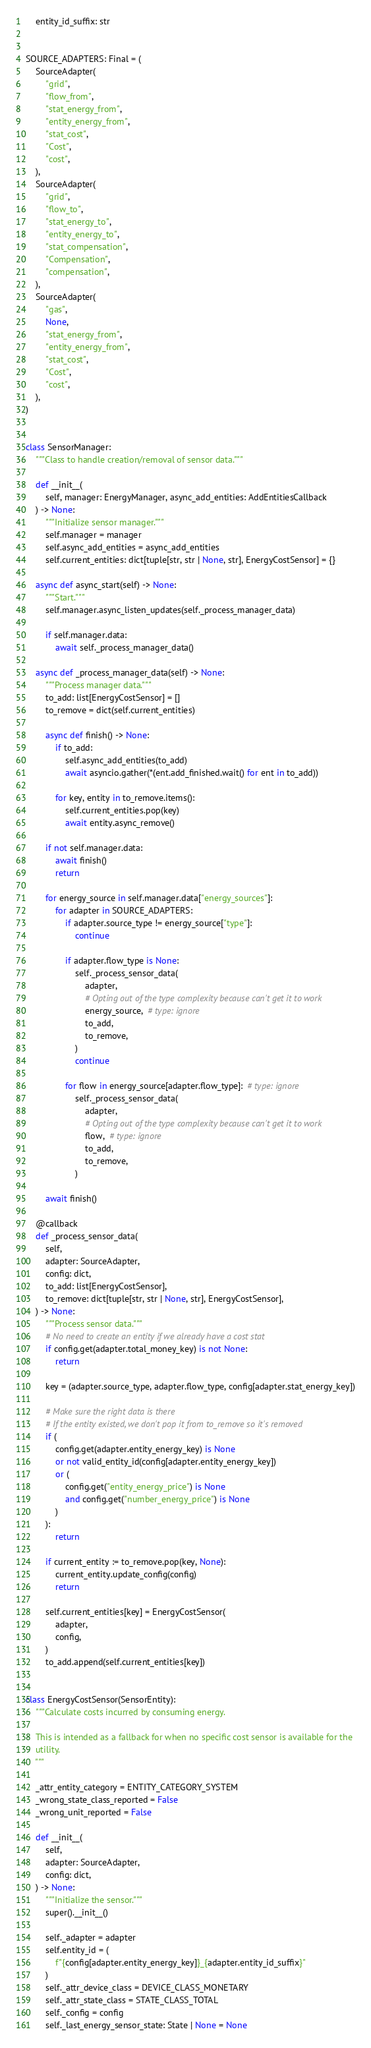<code> <loc_0><loc_0><loc_500><loc_500><_Python_>    entity_id_suffix: str


SOURCE_ADAPTERS: Final = (
    SourceAdapter(
        "grid",
        "flow_from",
        "stat_energy_from",
        "entity_energy_from",
        "stat_cost",
        "Cost",
        "cost",
    ),
    SourceAdapter(
        "grid",
        "flow_to",
        "stat_energy_to",
        "entity_energy_to",
        "stat_compensation",
        "Compensation",
        "compensation",
    ),
    SourceAdapter(
        "gas",
        None,
        "stat_energy_from",
        "entity_energy_from",
        "stat_cost",
        "Cost",
        "cost",
    ),
)


class SensorManager:
    """Class to handle creation/removal of sensor data."""

    def __init__(
        self, manager: EnergyManager, async_add_entities: AddEntitiesCallback
    ) -> None:
        """Initialize sensor manager."""
        self.manager = manager
        self.async_add_entities = async_add_entities
        self.current_entities: dict[tuple[str, str | None, str], EnergyCostSensor] = {}

    async def async_start(self) -> None:
        """Start."""
        self.manager.async_listen_updates(self._process_manager_data)

        if self.manager.data:
            await self._process_manager_data()

    async def _process_manager_data(self) -> None:
        """Process manager data."""
        to_add: list[EnergyCostSensor] = []
        to_remove = dict(self.current_entities)

        async def finish() -> None:
            if to_add:
                self.async_add_entities(to_add)
                await asyncio.gather(*(ent.add_finished.wait() for ent in to_add))

            for key, entity in to_remove.items():
                self.current_entities.pop(key)
                await entity.async_remove()

        if not self.manager.data:
            await finish()
            return

        for energy_source in self.manager.data["energy_sources"]:
            for adapter in SOURCE_ADAPTERS:
                if adapter.source_type != energy_source["type"]:
                    continue

                if adapter.flow_type is None:
                    self._process_sensor_data(
                        adapter,
                        # Opting out of the type complexity because can't get it to work
                        energy_source,  # type: ignore
                        to_add,
                        to_remove,
                    )
                    continue

                for flow in energy_source[adapter.flow_type]:  # type: ignore
                    self._process_sensor_data(
                        adapter,
                        # Opting out of the type complexity because can't get it to work
                        flow,  # type: ignore
                        to_add,
                        to_remove,
                    )

        await finish()

    @callback
    def _process_sensor_data(
        self,
        adapter: SourceAdapter,
        config: dict,
        to_add: list[EnergyCostSensor],
        to_remove: dict[tuple[str, str | None, str], EnergyCostSensor],
    ) -> None:
        """Process sensor data."""
        # No need to create an entity if we already have a cost stat
        if config.get(adapter.total_money_key) is not None:
            return

        key = (adapter.source_type, adapter.flow_type, config[adapter.stat_energy_key])

        # Make sure the right data is there
        # If the entity existed, we don't pop it from to_remove so it's removed
        if (
            config.get(adapter.entity_energy_key) is None
            or not valid_entity_id(config[adapter.entity_energy_key])
            or (
                config.get("entity_energy_price") is None
                and config.get("number_energy_price") is None
            )
        ):
            return

        if current_entity := to_remove.pop(key, None):
            current_entity.update_config(config)
            return

        self.current_entities[key] = EnergyCostSensor(
            adapter,
            config,
        )
        to_add.append(self.current_entities[key])


class EnergyCostSensor(SensorEntity):
    """Calculate costs incurred by consuming energy.

    This is intended as a fallback for when no specific cost sensor is available for the
    utility.
    """

    _attr_entity_category = ENTITY_CATEGORY_SYSTEM
    _wrong_state_class_reported = False
    _wrong_unit_reported = False

    def __init__(
        self,
        adapter: SourceAdapter,
        config: dict,
    ) -> None:
        """Initialize the sensor."""
        super().__init__()

        self._adapter = adapter
        self.entity_id = (
            f"{config[adapter.entity_energy_key]}_{adapter.entity_id_suffix}"
        )
        self._attr_device_class = DEVICE_CLASS_MONETARY
        self._attr_state_class = STATE_CLASS_TOTAL
        self._config = config
        self._last_energy_sensor_state: State | None = None</code> 